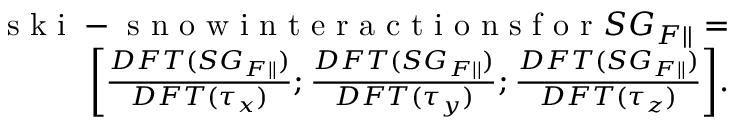Convert formula to latex. <formula><loc_0><loc_0><loc_500><loc_500>\begin{array} { r } { s k i - s n o w i n t e r a c t i o n s f o r S G _ { F | | } = } \\ { \left [ \frac { D F T ( S G _ { F | | } ) } { D F T ( \tau _ { x } ) } ; \frac { D F T ( S G _ { F | | } ) } { D F T ( \tau _ { y } ) } ; \frac { D F T ( S G _ { F | | } ) } { D F T ( \tau _ { z } ) } \right ] . } \end{array}</formula> 